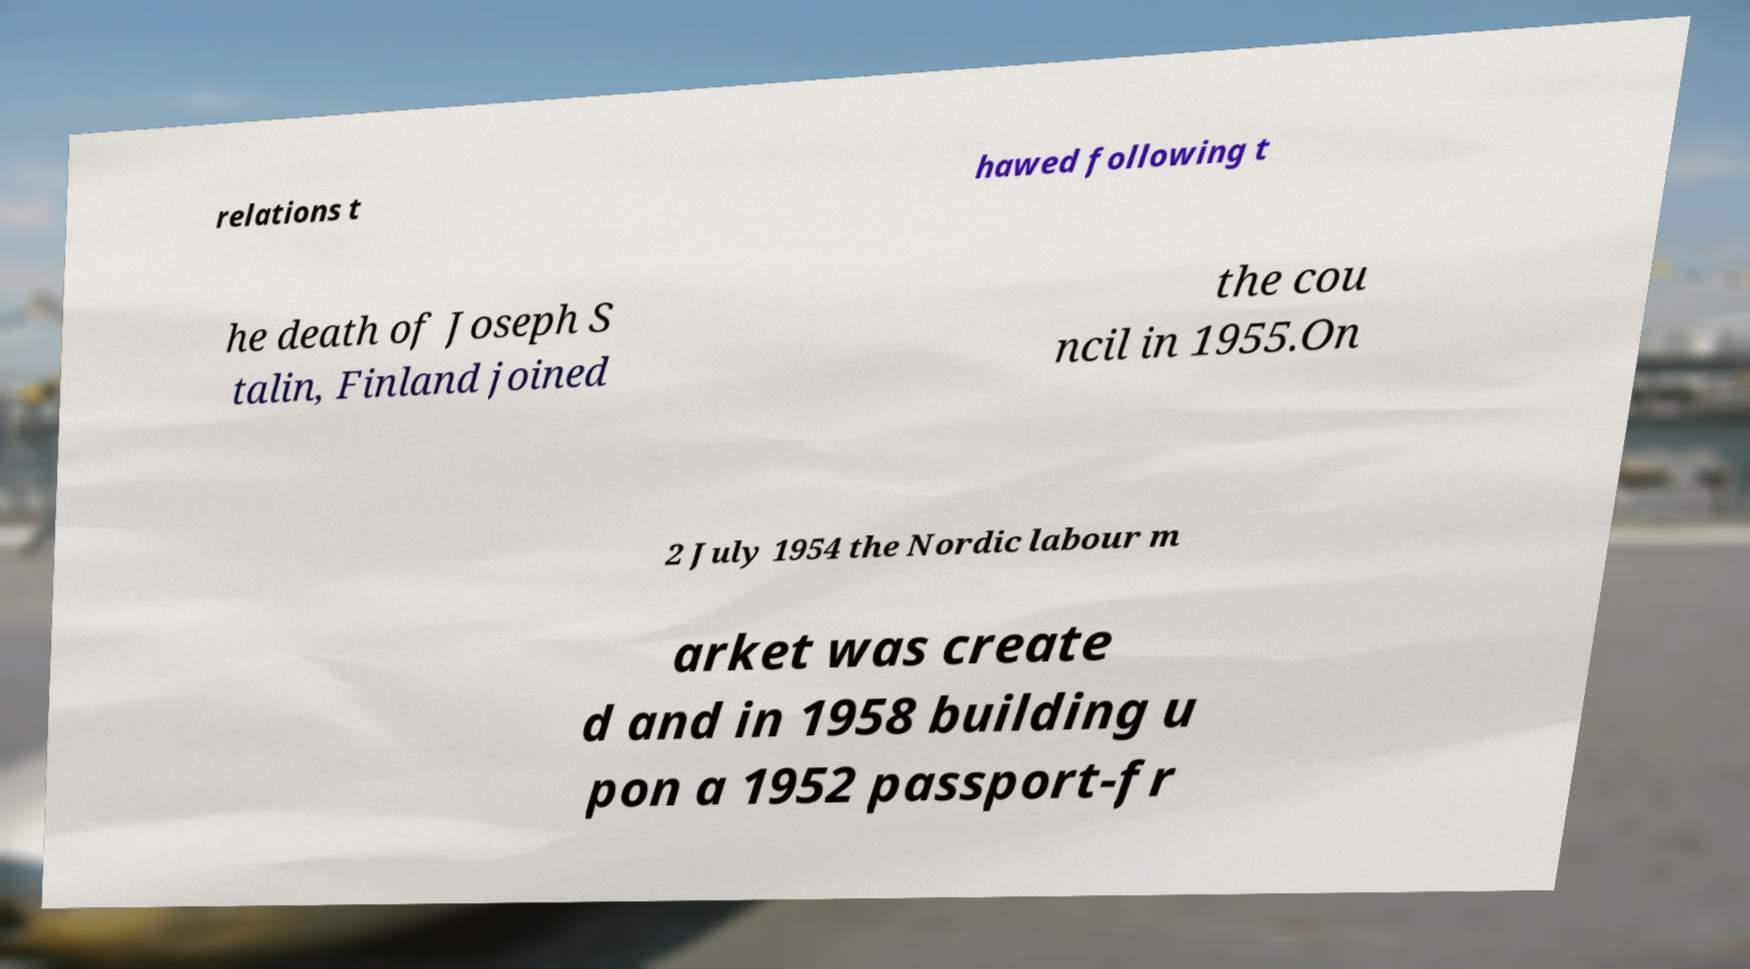Please identify and transcribe the text found in this image. relations t hawed following t he death of Joseph S talin, Finland joined the cou ncil in 1955.On 2 July 1954 the Nordic labour m arket was create d and in 1958 building u pon a 1952 passport-fr 